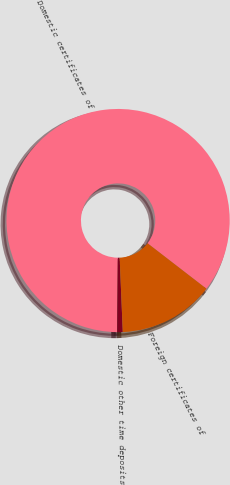Convert chart. <chart><loc_0><loc_0><loc_500><loc_500><pie_chart><fcel>Domestic certificates of<fcel>Domestic other time deposits<fcel>Foreign certificates of<nl><fcel>85.35%<fcel>0.79%<fcel>13.87%<nl></chart> 